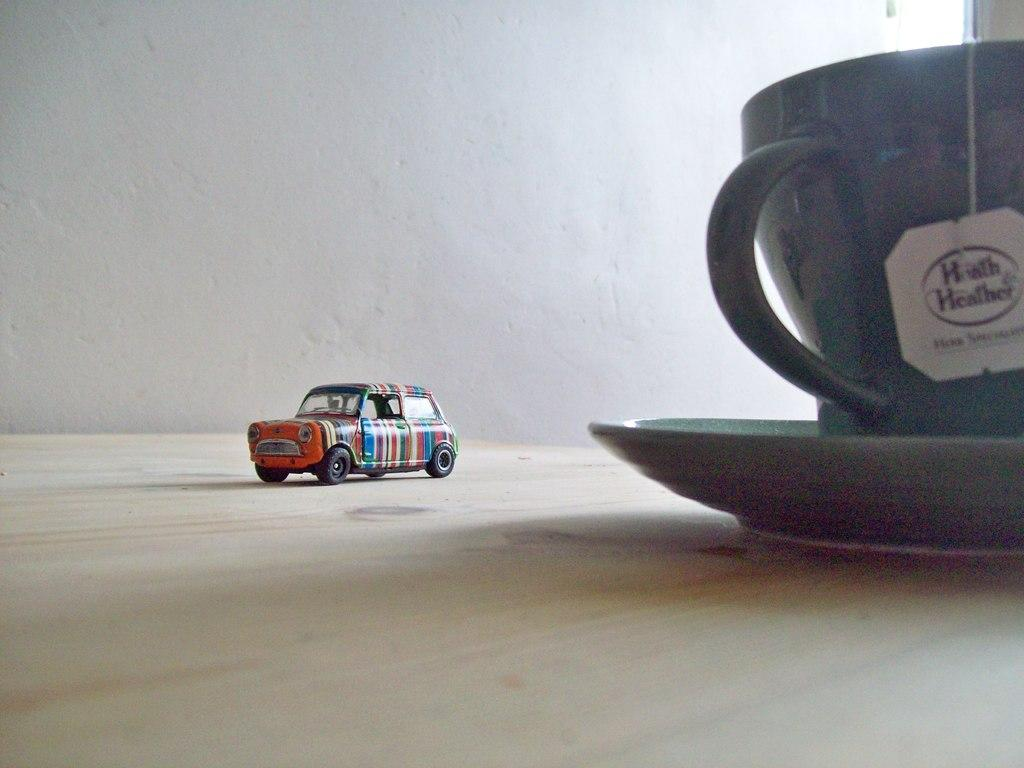What type of toy is in the image? There is a toy car in the image. What other objects can be seen in the image? There is a cup and a saucer in the image. Where are the cup and saucer located? The cup and saucer are placed on a table. What is visible in the background of the image? There is a wall in the background of the image. How does the toy car perform magic tricks in the image? The toy car does not perform magic tricks in the image; it is simply a toy car. What type of wind can be seen blowing through the image? There is no wind visible in the image. 